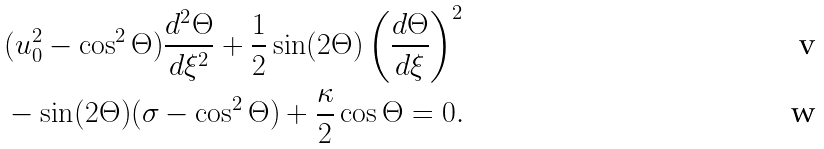<formula> <loc_0><loc_0><loc_500><loc_500>& ( u _ { 0 } ^ { 2 } - \cos ^ { 2 } \Theta ) \frac { d ^ { 2 } \Theta } { d \xi ^ { 2 } } + \frac { 1 } { 2 } \sin ( 2 \Theta ) \left ( \frac { d \Theta } { d \xi } \right ) ^ { 2 } \\ & - \sin ( 2 \Theta ) ( \sigma - \cos ^ { 2 } \Theta ) + \frac { \kappa } { 2 } \cos \Theta = 0 .</formula> 